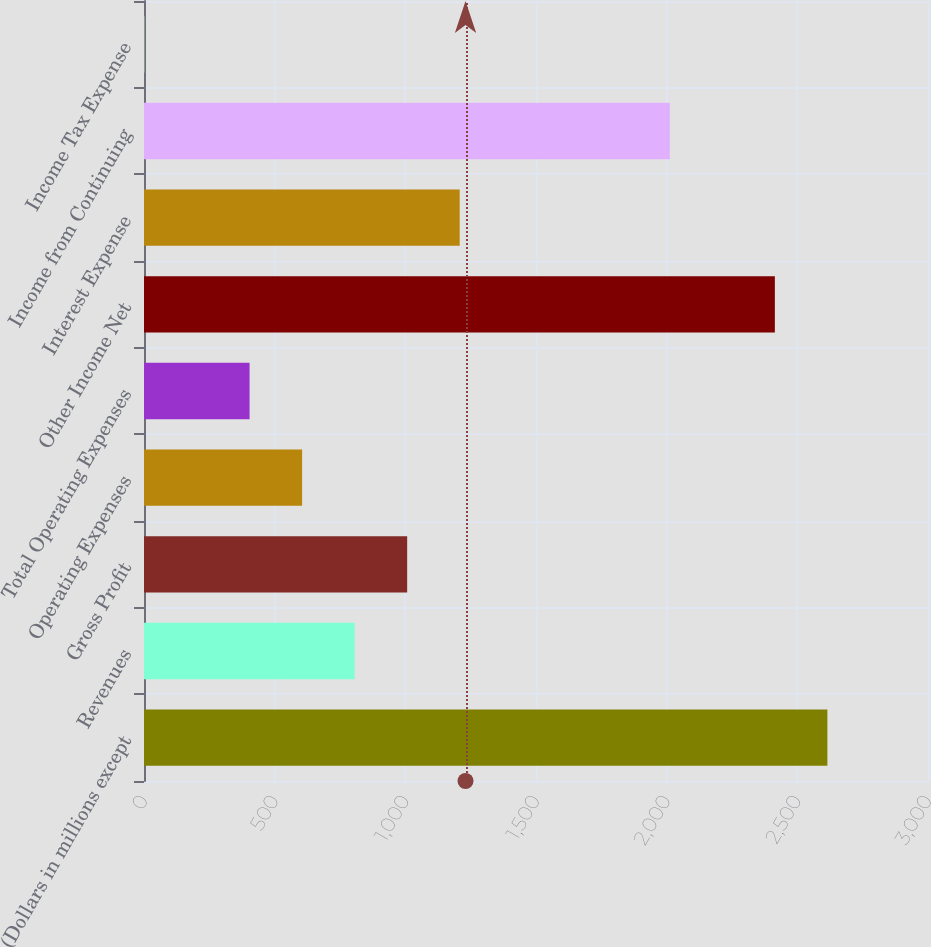Convert chart. <chart><loc_0><loc_0><loc_500><loc_500><bar_chart><fcel>(Dollars in millions except<fcel>Revenues<fcel>Gross Profit<fcel>Operating Expenses<fcel>Total Operating Expenses<fcel>Other Income Net<fcel>Interest Expense<fcel>Income from Continuing<fcel>Income Tax Expense<nl><fcel>2615<fcel>806<fcel>1007<fcel>605<fcel>404<fcel>2414<fcel>1208<fcel>2012<fcel>2<nl></chart> 